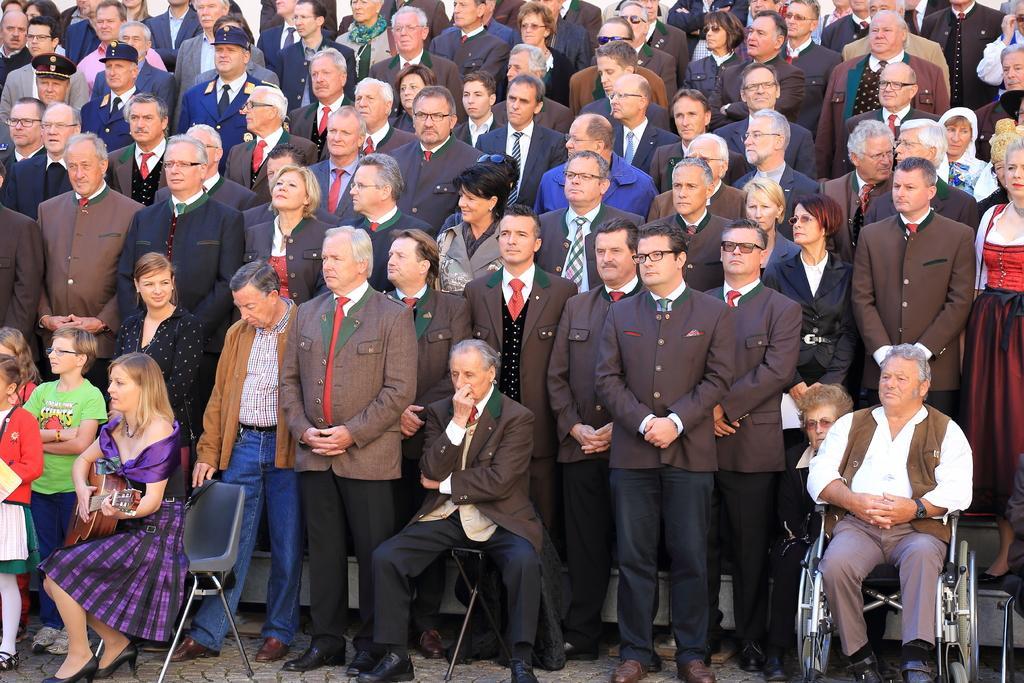Please provide a concise description of this image. In this image I can see group of people standing. In front the person is sitting and holding the musical instrument and the person is wearing purple and black color dress and the person at right is wearing white and brown color dress. 